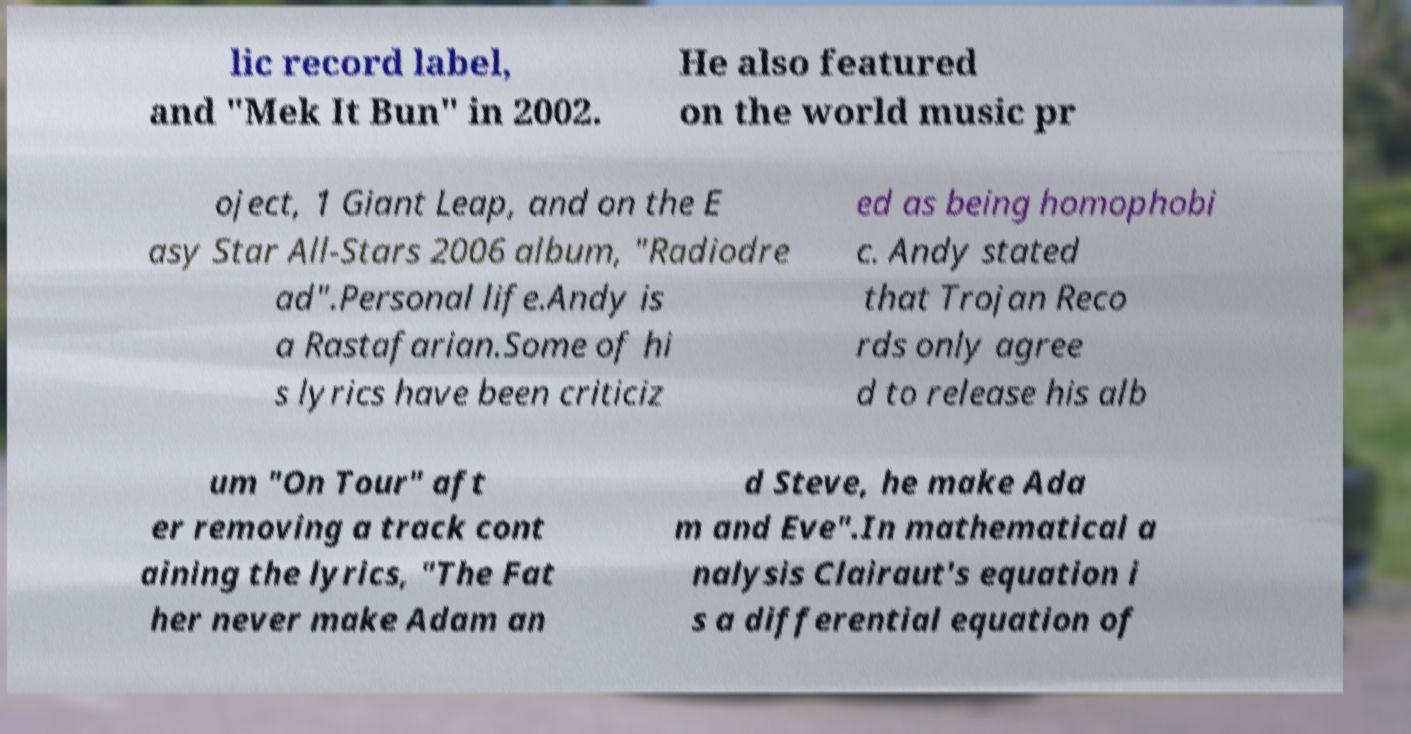What messages or text are displayed in this image? I need them in a readable, typed format. lic record label, and "Mek It Bun" in 2002. He also featured on the world music pr oject, 1 Giant Leap, and on the E asy Star All-Stars 2006 album, "Radiodre ad".Personal life.Andy is a Rastafarian.Some of hi s lyrics have been criticiz ed as being homophobi c. Andy stated that Trojan Reco rds only agree d to release his alb um "On Tour" aft er removing a track cont aining the lyrics, "The Fat her never make Adam an d Steve, he make Ada m and Eve".In mathematical a nalysis Clairaut's equation i s a differential equation of 